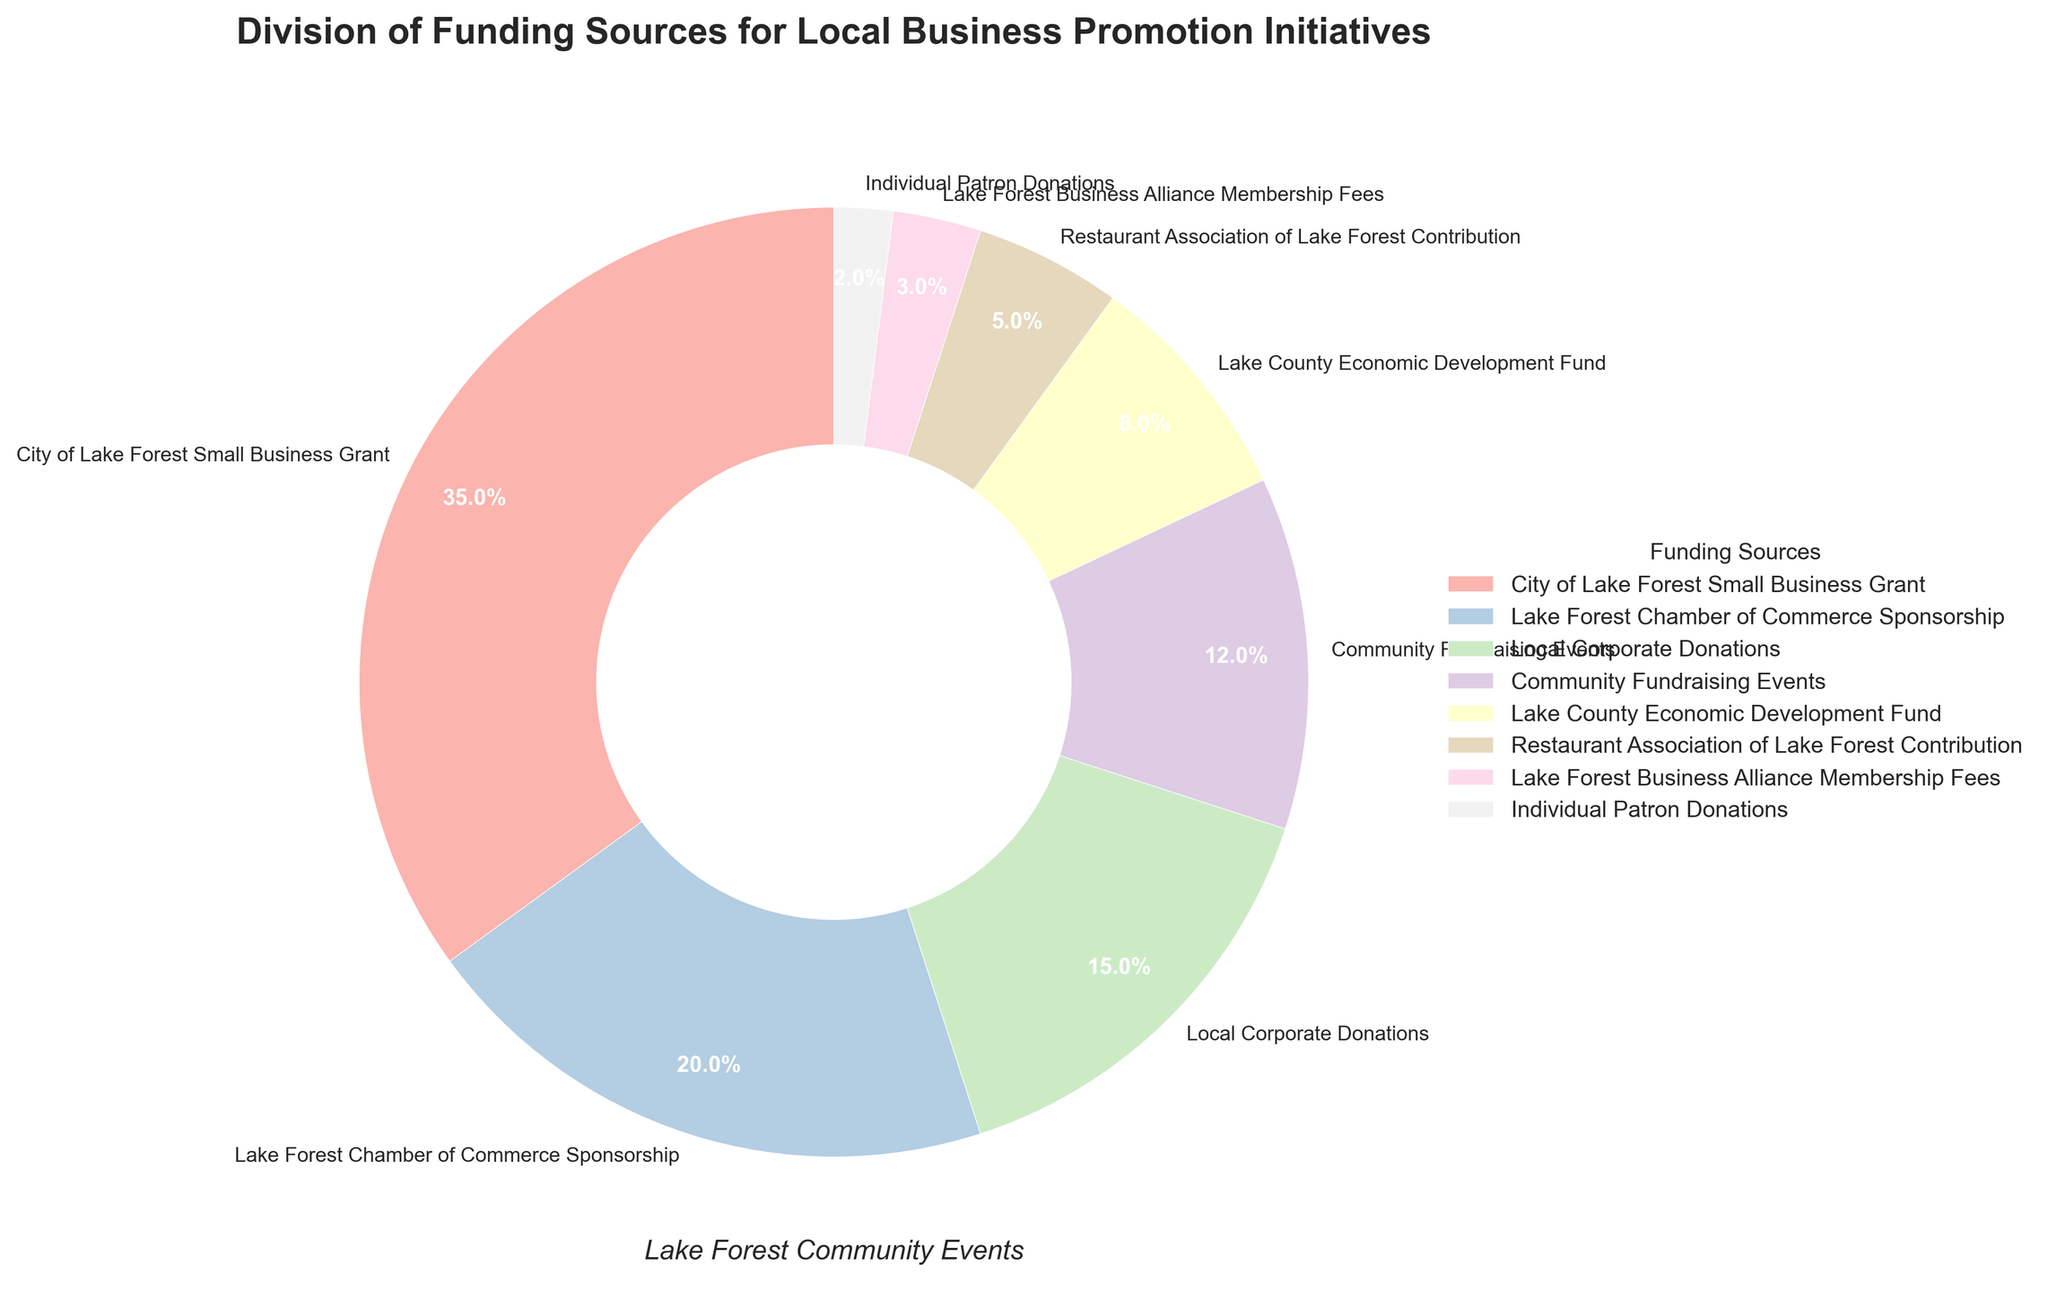How much more funding does the City of Lake Forest Small Business Grant provide compared to the Lake Forest Chamber of Commerce Sponsorship? The percentage for City of Lake Forest Small Business Grant is 35% and for Lake Forest Chamber of Commerce Sponsorship is 20%. The difference is 35% - 20% = 15%.
Answer: 15% What is the combined percentage of funding from Community Fundraising Events, Lake County Economic Development Fund, Restaurant Association of Lake Forest Contribution, and Individual Patron Donations? The percentages are 12%, 8%, 5%, and 2% respectively. Summing these up: 12% + 8% + 5% + 2% = 27%.
Answer: 27% Which funding source contributes the least amount? The smallest slice of the pie chart represents Individual Patron Donations at 2%.
Answer: Individual Patron Donations What is the difference in percentage points between the largest and smallest funding sources? The largest funding source is the City of Lake Forest Small Business Grant at 35%, and the smallest is Individual Patron Donations at 2%. The difference is 35% - 2% = 33%.
Answer: 33% Are Lake Forest Chamber of Commerce Sponsorship and Local Corporate Donations combined greater than City of Lake Forest Small Business Grant? Lake Forest Chamber of Commerce Sponsorship is 20% and Local Corporate Donations is 15%. Combined, they are 20% + 15% = 35%. The City of Lake Forest Small Business Grant is also 35%, so they are equal.
Answer: Equal Which two funding sources together make up half of the total funding? The two largest sources are City of Lake Forest Small Business Grant (35%) and Lake Forest Chamber of Commerce Sponsorship (20%). Together they make up 35% + 20% = 55%, which is more than half. By checking further combinations, City of Lake Forest Small Business Grant (35%) and Local Corporate Donations (15%) make up 50%.
Answer: City of Lake Forest Small Business Grant and Local Corporate Donations Is the percentage of funding from Local Corporate Donations higher than the combined percentage from Restaurant Association of Lake Forest Contribution and Lake Forest Business Alliance Membership Fees? Local Corporate Donations contribute 15%. Restaurant Association of Lake Forest Contribution is 5% and Lake Forest Business Alliance Membership Fees is 3%, combined they make 5% + 3% = 8%, which is less than 15%.
Answer: Yes What is the sum of the percentages of the four smallest funding sources? The four smallest sources are Lake Forest Business Alliance Membership Fees (3%), Restaurant Association of Lake Forest Contribution (5%), Lake County Economic Development Fund (8%), and Individual Patron Donations (2%). Summing these up: 3% + 5% + 8% + 2% = 18%.
Answer: 18% What is the average percentage of funding for all sources listed? There are 8 funding sources. The total sum is 35% + 20% + 15% + 12% + 8% + 5% + 3% + 2% = 100%. The average is 100% / 8 = 12.5%.
Answer: 12.5% How does the contribution from Community Fundraising Events compare to Local Corporate Donations? Community Fundraising Events contribute 12%, and Local Corporate Donations contribute 15%. Therefore, Community Fundraising Events contribute 3% less than Local Corporate Donations.
Answer: 3% less 